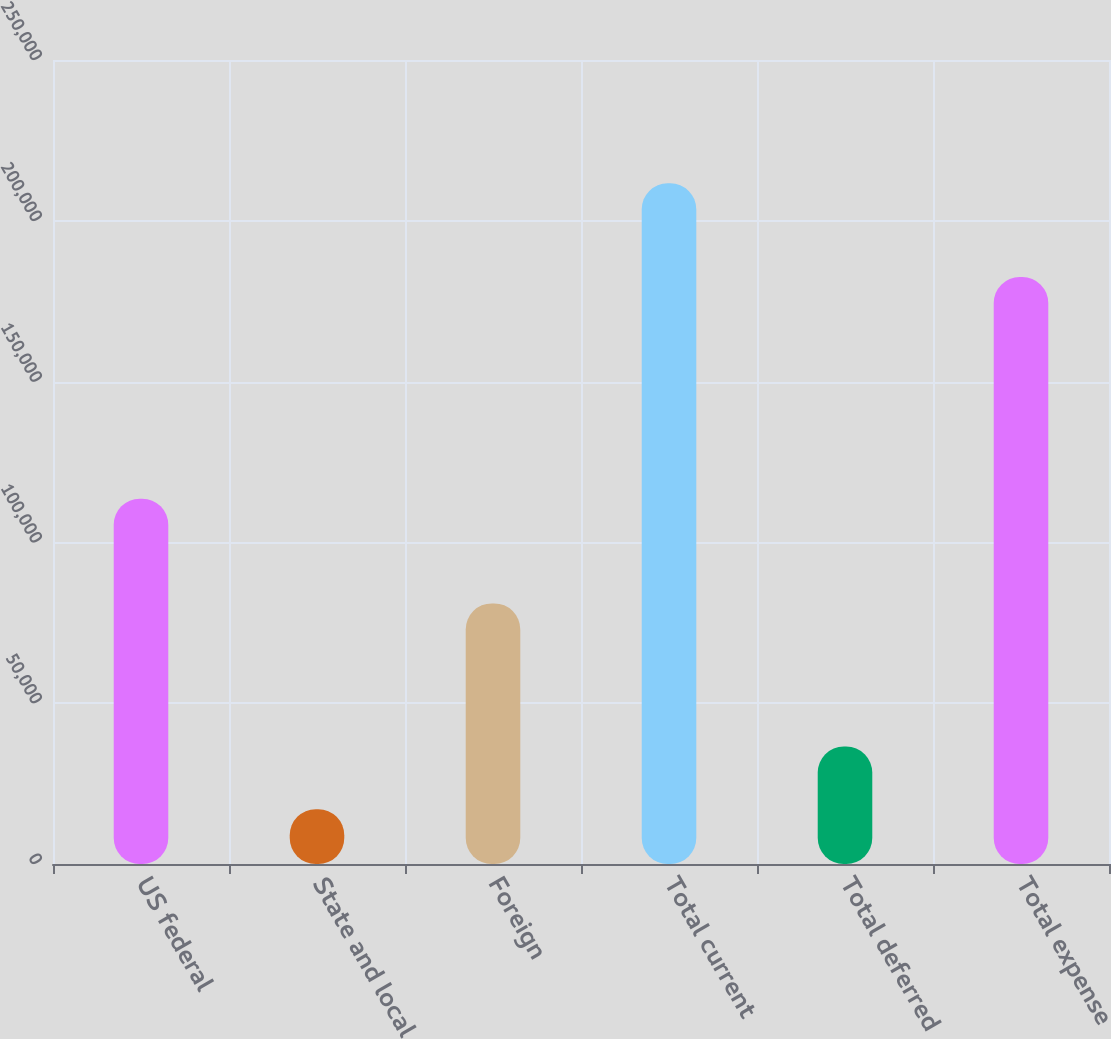Convert chart. <chart><loc_0><loc_0><loc_500><loc_500><bar_chart><fcel>US federal<fcel>State and local<fcel>Foreign<fcel>Total current<fcel>Total deferred<fcel>Total expense<nl><fcel>113591<fcel>17037<fcel>81034<fcel>211662<fcel>36499.5<fcel>182516<nl></chart> 